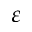<formula> <loc_0><loc_0><loc_500><loc_500>\varepsilon</formula> 